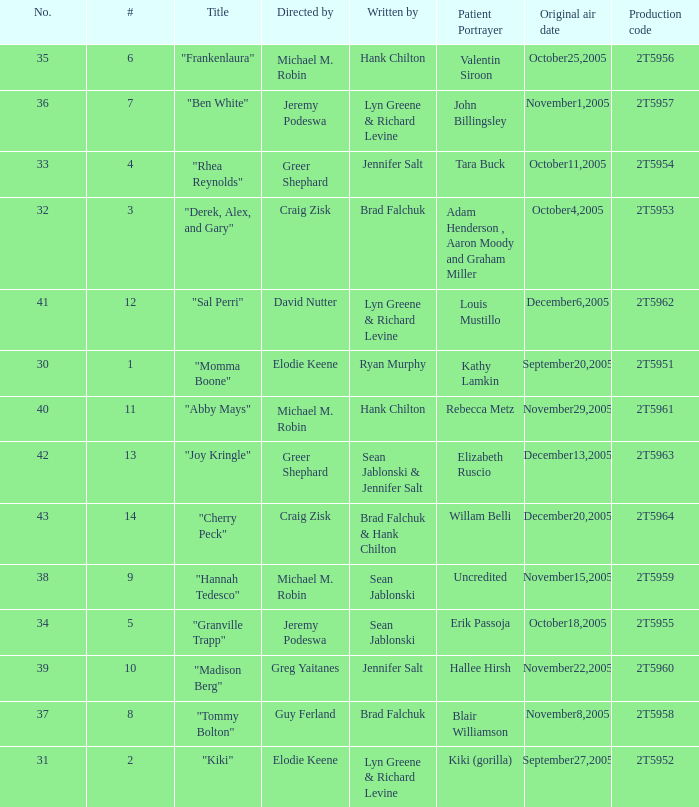What is the total number of patient portayers for the episode directed by Craig Zisk and written by Brad Falchuk? 1.0. 